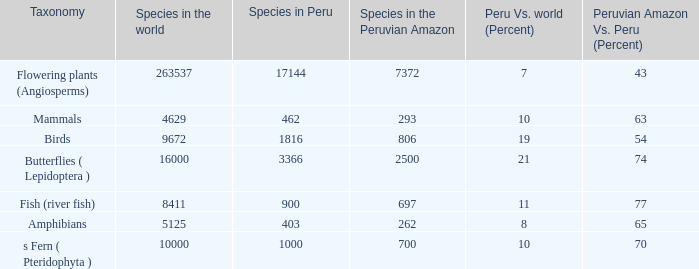What's the species in the world with peruvian amazon vs. peru (percent)  of 63 4629.0. 